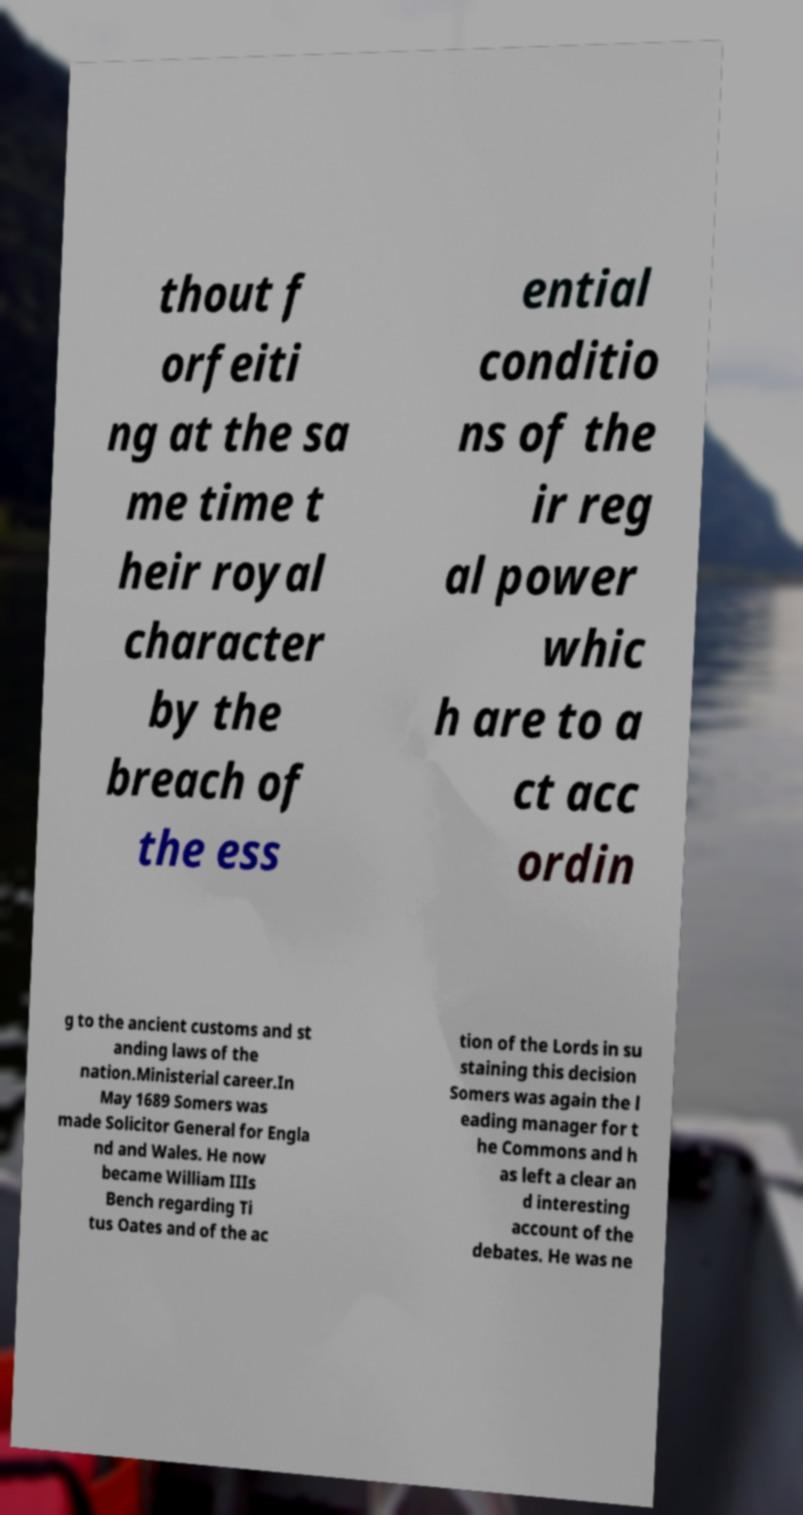What messages or text are displayed in this image? I need them in a readable, typed format. thout f orfeiti ng at the sa me time t heir royal character by the breach of the ess ential conditio ns of the ir reg al power whic h are to a ct acc ordin g to the ancient customs and st anding laws of the nation.Ministerial career.In May 1689 Somers was made Solicitor General for Engla nd and Wales. He now became William IIIs Bench regarding Ti tus Oates and of the ac tion of the Lords in su staining this decision Somers was again the l eading manager for t he Commons and h as left a clear an d interesting account of the debates. He was ne 